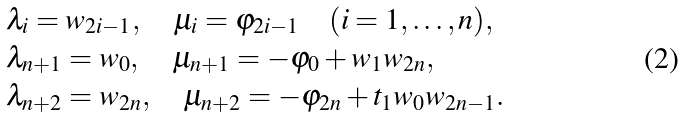<formula> <loc_0><loc_0><loc_500><loc_500>& \lambda _ { i } = w _ { 2 i - 1 } , \quad \mu _ { i } = \varphi _ { 2 i - 1 } \quad ( i = 1 , \dots , n ) , \\ & \lambda _ { n + 1 } = w _ { 0 } , \quad \mu _ { n + 1 } = - \varphi _ { 0 } + w _ { 1 } w _ { 2 n } , \\ & \lambda _ { n + 2 } = w _ { 2 n } , \quad \mu _ { n + 2 } = - \varphi _ { 2 n } + t _ { 1 } w _ { 0 } w _ { 2 n - 1 } .</formula> 